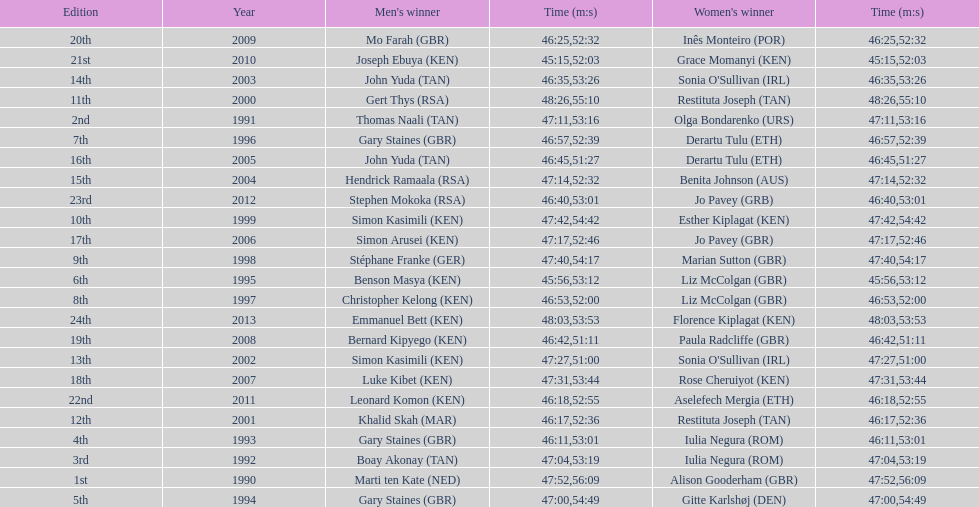How many men champions achieved times under or equal to 46 minutes? 2. 